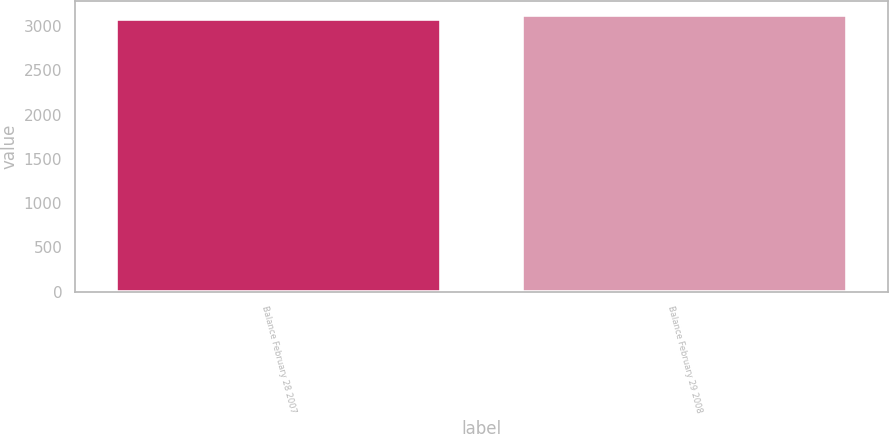<chart> <loc_0><loc_0><loc_500><loc_500><bar_chart><fcel>Balance February 28 2007<fcel>Balance February 29 2008<nl><fcel>3083.9<fcel>3123.9<nl></chart> 